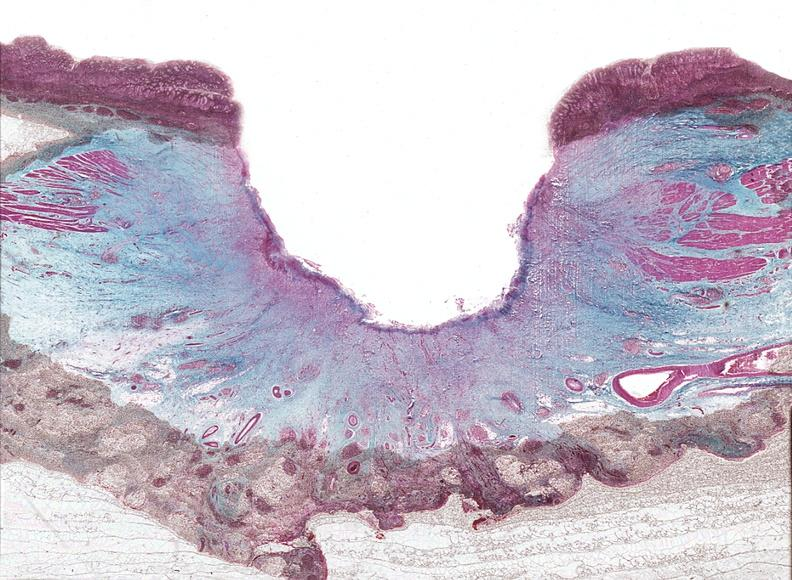does this image show stomach, chronic peptic ulcer?
Answer the question using a single word or phrase. Yes 